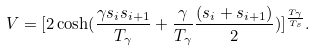Convert formula to latex. <formula><loc_0><loc_0><loc_500><loc_500>V = [ 2 \cosh ( \frac { \gamma s _ { i } s _ { i + 1 } } { T _ { \gamma } } + \frac { \gamma } { T _ { \gamma } } \frac { ( s _ { i } + s _ { i + 1 } ) } { 2 } ) ] ^ { \frac { T _ { \gamma } } { T _ { s } } } .</formula> 